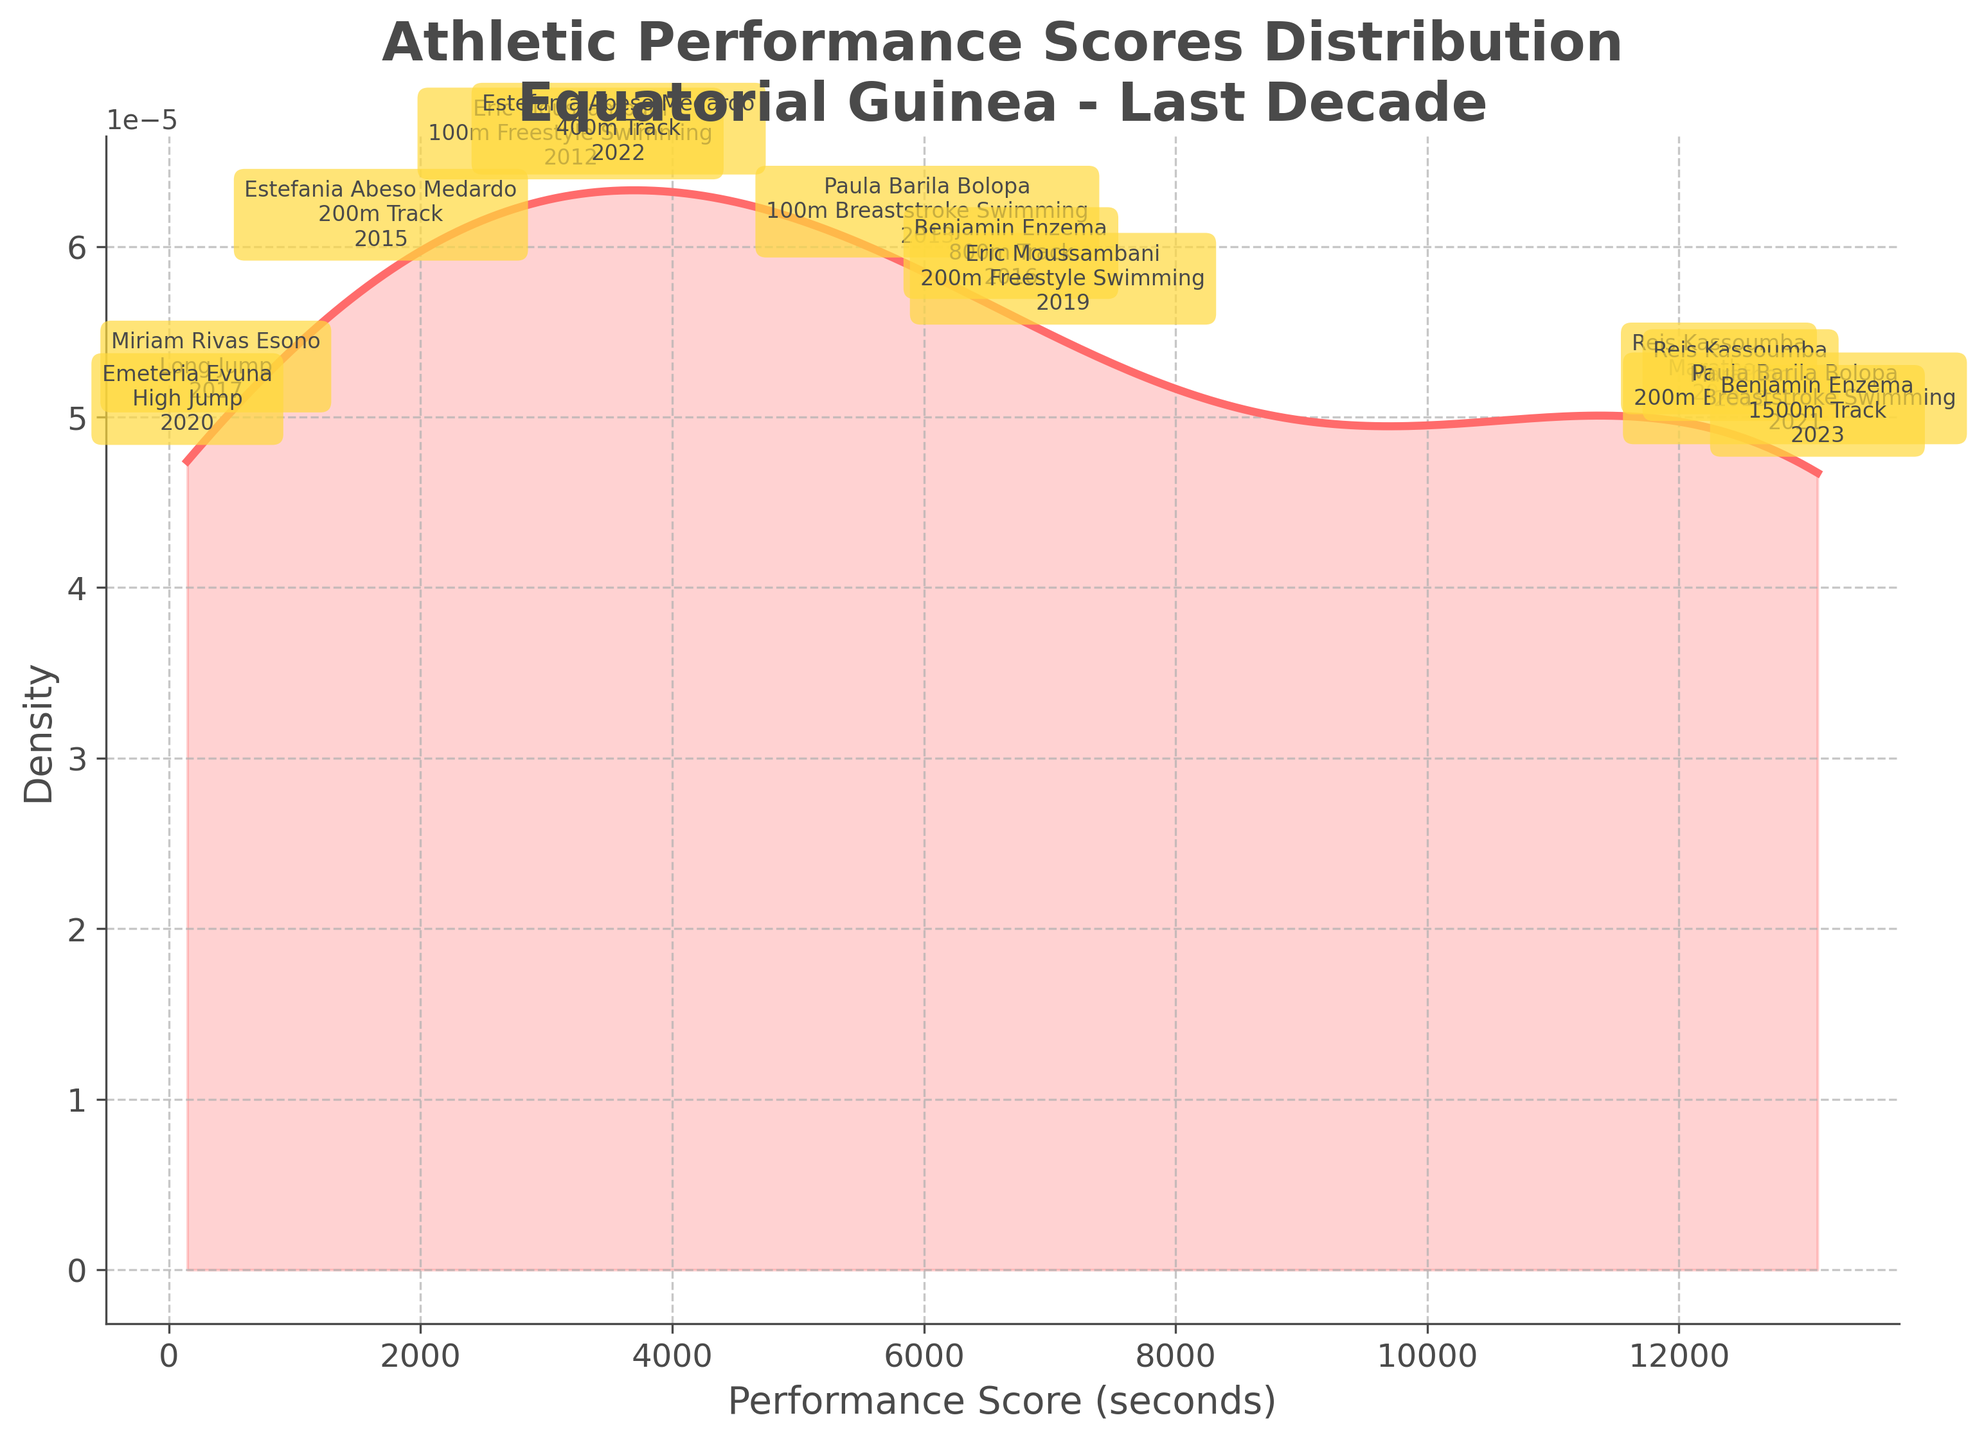What is the title of the density plot? The title of the density plot is typically displayed prominently at the top of the figure. It provides an overview of what the plot represents and the context of the data. In this case, the title is "Athletic Performance Scores Distribution\nEquatorial Guinea - Last Decade".
Answer: Athletic Performance Scores Distribution\nEquatorial Guinea - Last Decade What does the x-axis of the density plot represent? The x-axis label is usually located below the horizontal axis and describes the variable plotted along this axis. In the figure, the x-axis represents "Performance Score (seconds)", indicating the athletic performance scores converted into seconds.
Answer: Performance Score (seconds) How many distinct athletes' performances are annotated on the plot? Each data point representing an athlete’s performance is annotated individually with the athlete's name, event, and year. By counting these annotations, we can determine the number of distinct performances. Based on the provided data, there are 11 annotated performances.
Answer: 11 What is the general shape of the density curve? The shape of the density curve can be observed visually. It typically shows how the data points are distributed over the range of the x-axis values. The curve in this plot indicates where the scores are concentrated and where they are sparse.
Answer: The density curve has one main peak and gradually decreases on either side Which athlete's performance score appears near the peak of the density curve? To identify which performance score appears near the peak of the density curve, we need to look at the annotations near the highest point of the curve. The athlete corresponding to this peak can be inferred from these annotations.
Answer: Estefania Abeso Medardo (27.65 seconds, 200m Track) What is the performance score range covered by the density plot? The range is determined by looking at the minimum and maximum values on the x-axis. The axis labels and tick marks give an indication of the spread of performance scores plotted. In this figure, it extends from around 20 seconds to 13000 seconds (approximately).
Answer: 20 seconds to 13000 seconds Which event had the highest performance score and who was the athlete? By observing the annotations, we can determine which event and athlete correspond to the highest performance score value on the x-axis. The highest score on the plot is 3:35:21 (200m Breaststroke Swimming by Paula Barila Bolopa).
Answer: Paula Barila Bolopa, 200m Breaststroke Swimming How do Benjamin Enzema's performance scores change from 2016 to 2023? To compare Benjamin Enzema's scores over the years, we look at his performances annotated for 2016 (800m Track) and 2023 (1500m Track). Comparing the annotated performance scores shows the change over time.
Answer: From 1:50.91 in 2016 to 3:37.80 in 2023 Are there any gaps or regions with low density in the performance scores distribution? The regions of low density on a density plot can be identified by observing where the curve dips or has minimal height. These indicate ranges with fewer or no data points. In this plot, there is a notable dip in density between shorter and longer distances.
Answer: Yes, there are gaps in the middle range of the scores How does Miriam Rivas Esono's long jump performance fit within the overall distribution? To see where Miriam Rivas Esono's long jump score fits, we check her annotation on the plot and see its position relative to the density curve. It shows her score (6.13 seconds) in comparison to the overall performance scores distribution.
Answer: It is on the lower end of the score distribution 